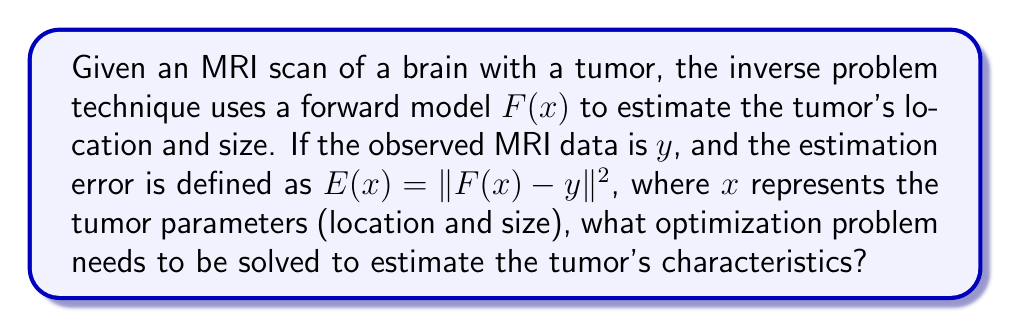Could you help me with this problem? To estimate the brain tumor's location and size from MRI scans using inverse problem techniques, we need to follow these steps:

1. Understand the problem:
   - We have a forward model $F(x)$ that simulates MRI data for given tumor parameters $x$.
   - We have observed MRI data $y$.
   - We want to find the tumor parameters $x$ that best explain the observed data.

2. Define the estimation error:
   The estimation error is given by $E(x) = ||F(x) - y||^2$, where:
   - $F(x)$ is the simulated MRI data for tumor parameters $x$
   - $y$ is the observed MRI data
   - $||.||^2$ denotes the squared L2 norm (sum of squared differences)

3. Formulate the optimization problem:
   To find the best estimate of tumor parameters, we need to minimize the estimation error. This can be expressed as:

   $$\min_x E(x) = \min_x ||F(x) - y||^2$$

4. Recognize the implications:
   - This is a least squares optimization problem.
   - Solving this problem will give us the tumor parameters $x$ that minimize the difference between the simulated and observed MRI data.
   - The solution $x$ will contain the estimated tumor location and size.

5. Consider practical aspects:
   - In practice, this optimization problem may be solved using iterative methods like gradient descent or Gauss-Newton algorithm.
   - The forward model $F(x)$ may be complex and nonlinear, making the optimization challenging.
   - Additional regularization terms may be added to the optimization problem to ensure stability and incorporate prior knowledge about tumor characteristics.
Answer: $$\min_x ||F(x) - y||^2$$ 